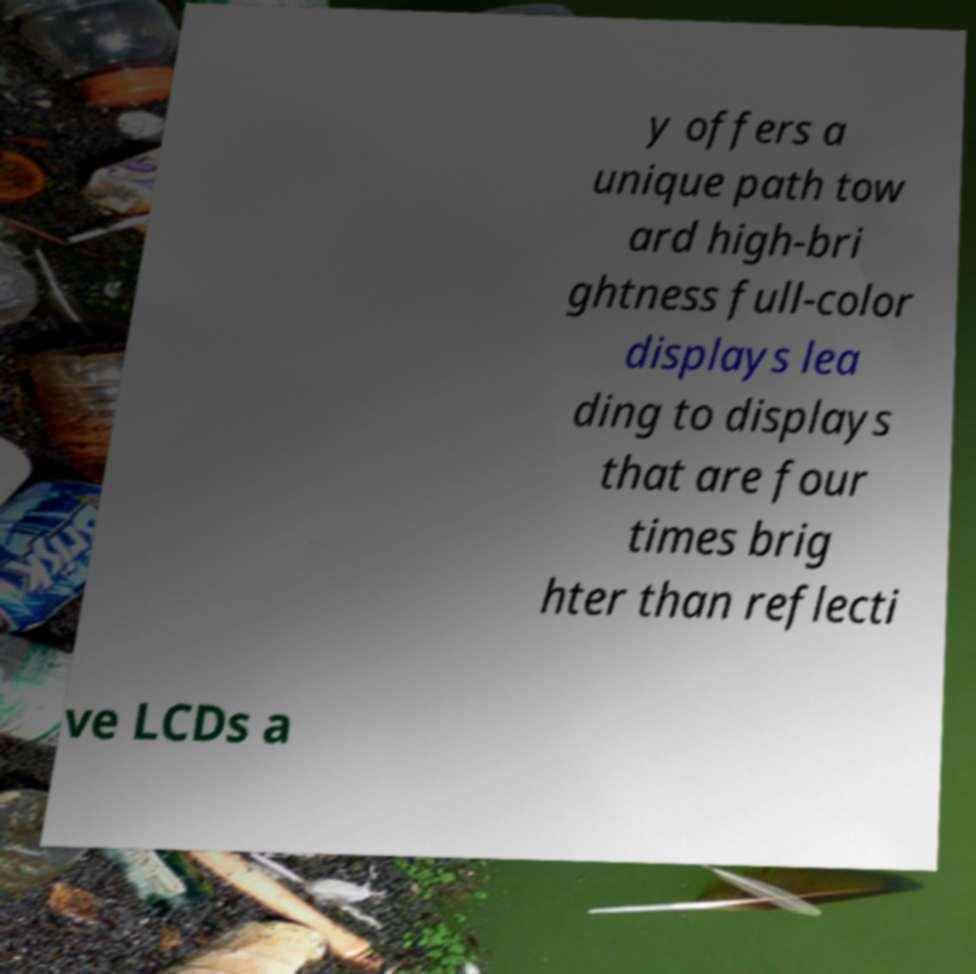Can you read and provide the text displayed in the image?This photo seems to have some interesting text. Can you extract and type it out for me? y offers a unique path tow ard high-bri ghtness full-color displays lea ding to displays that are four times brig hter than reflecti ve LCDs a 